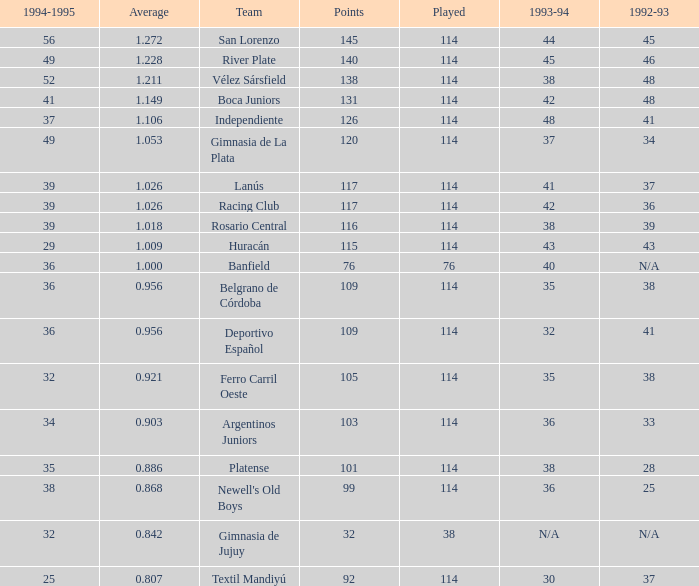Name the most played 114.0. 